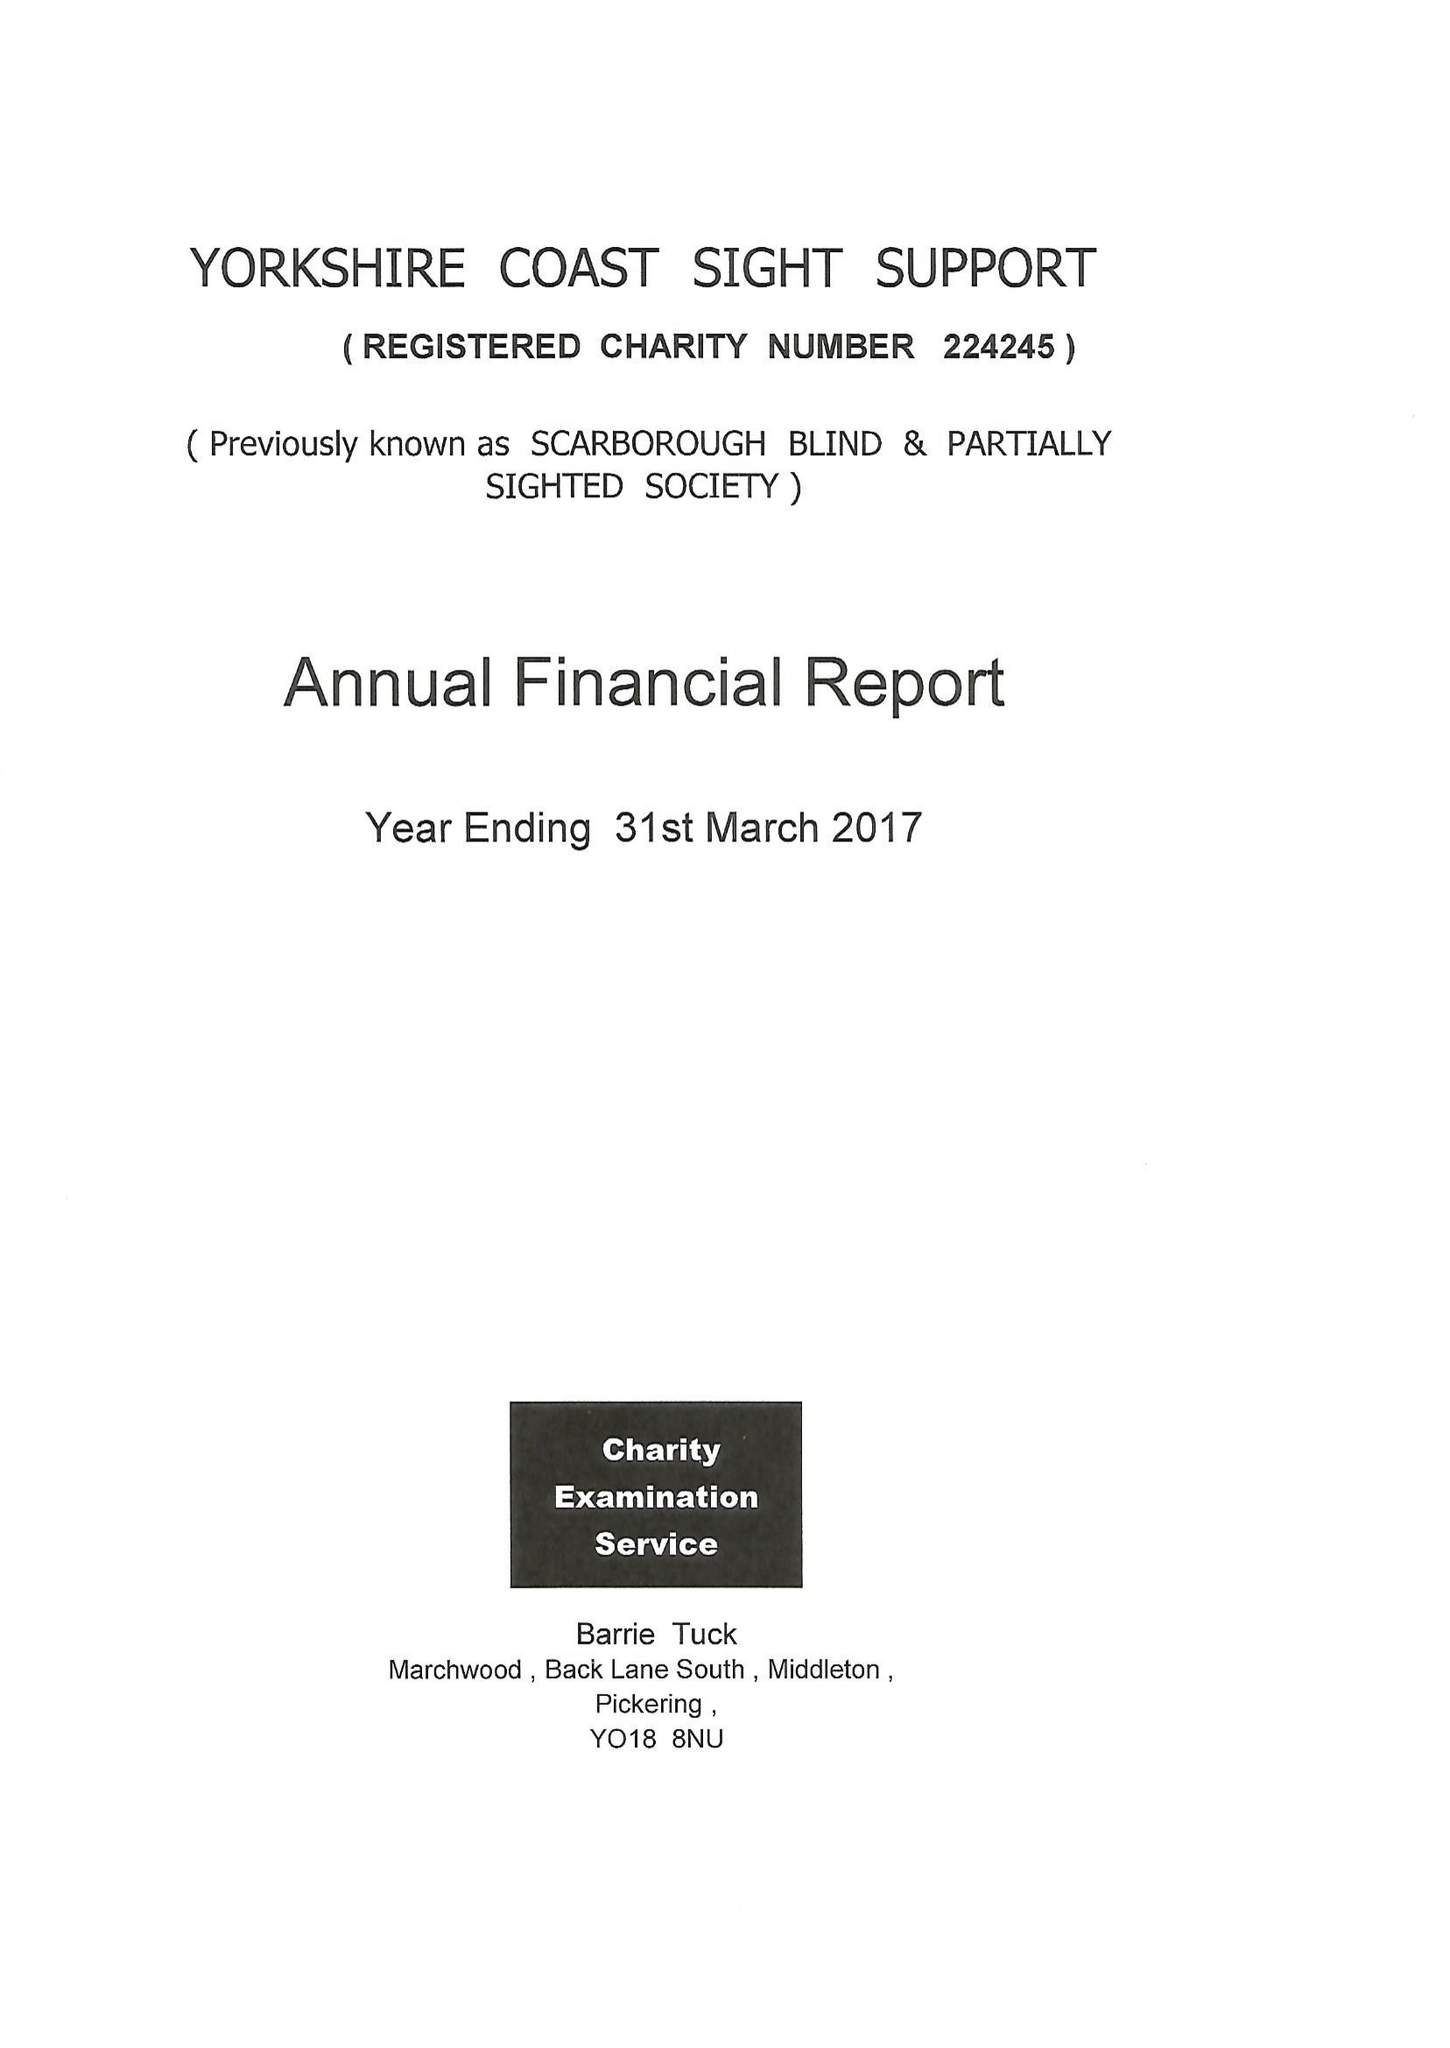What is the value for the address__postcode?
Answer the question using a single word or phrase. YO12 7JH 